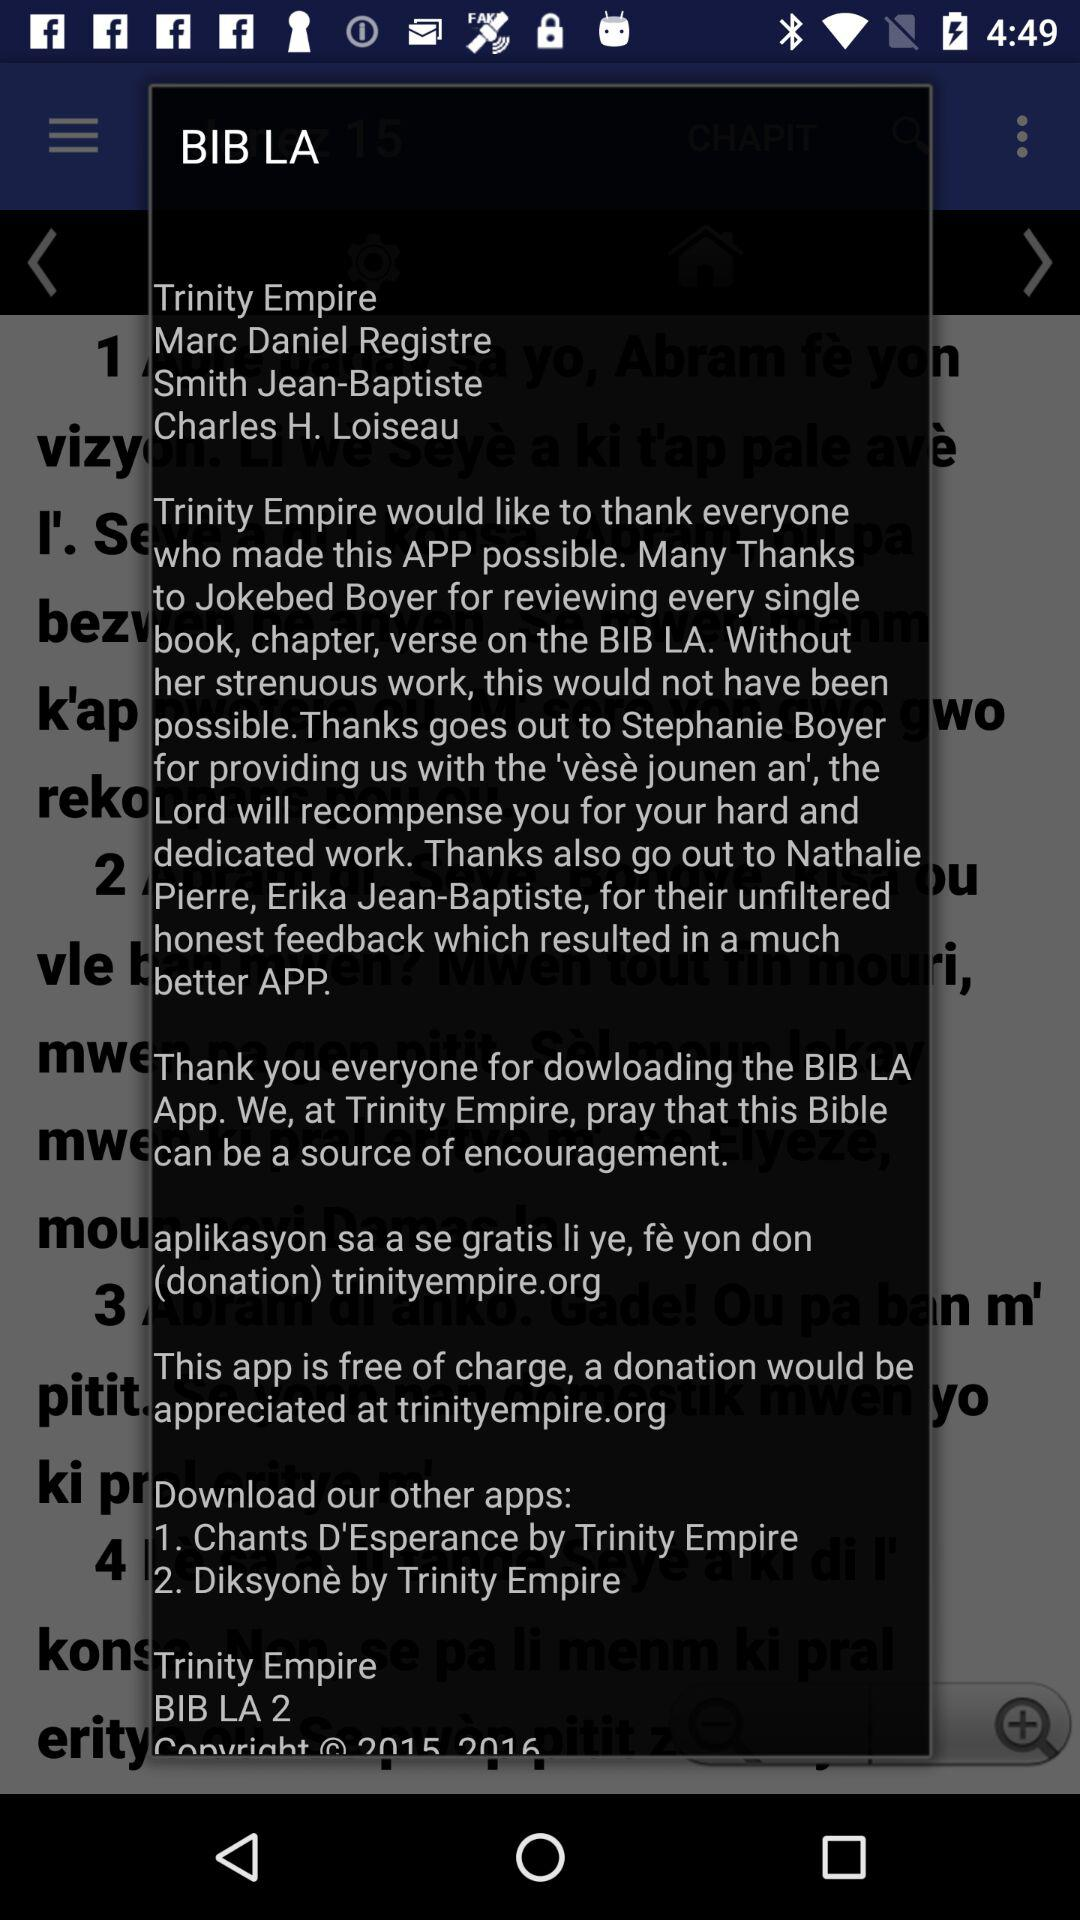What are the steps to downloading the other applications?
When the provided information is insufficient, respond with <no answer>. <no answer> 